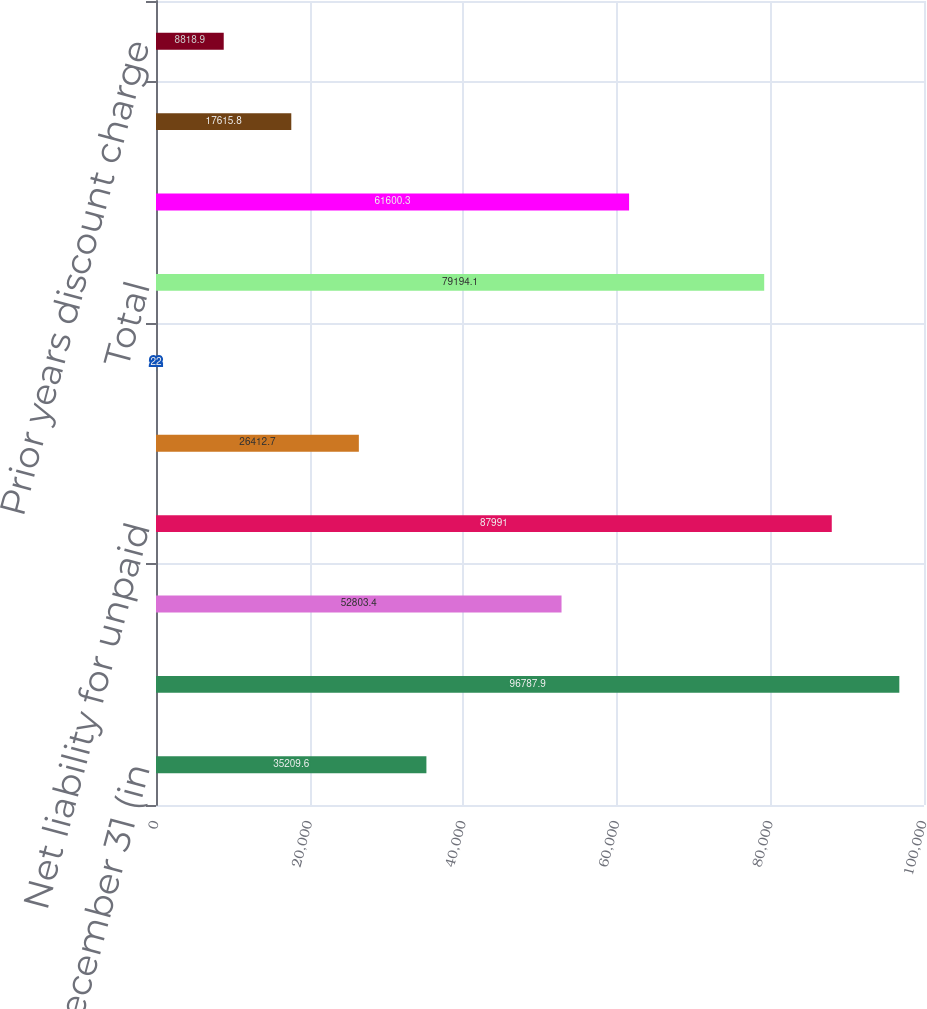<chart> <loc_0><loc_0><loc_500><loc_500><bar_chart><fcel>Years Ended December 31 (in<fcel>Liability for unpaid losses<fcel>Reinsurance recoverable<fcel>Net liability for unpaid<fcel>Foreign exchange effect<fcel>Changes in net loss reserves<fcel>Total<fcel>Current year<fcel>Prior years excluding discount<fcel>Prior years discount charge<nl><fcel>35209.6<fcel>96787.9<fcel>52803.4<fcel>87991<fcel>26412.7<fcel>22<fcel>79194.1<fcel>61600.3<fcel>17615.8<fcel>8818.9<nl></chart> 